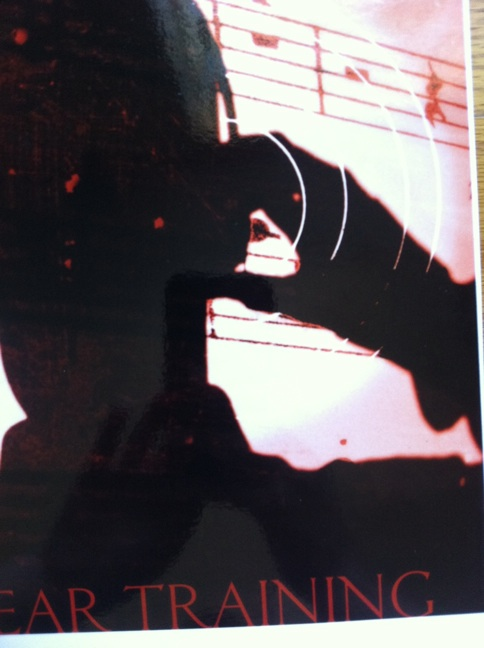If this image were the cover of a book, what would the title and synopsis be? Title: 'Echoes of the Soul'
Synopsis: 'Echoes of the Soul' follows the journey of a young musician, Maya, who discovers the power of ear training and its ability to transform her musical abilities. As Maya navigates the challenges of conservatory life, personal struggles, and professional competitions, she learns that true mastery of music lies not just in the technicalities but in the resonance of the soul. This inspiring tale intertwines elements of dedication, passion, and the relentless pursuit of one’s dreams against all odds. 